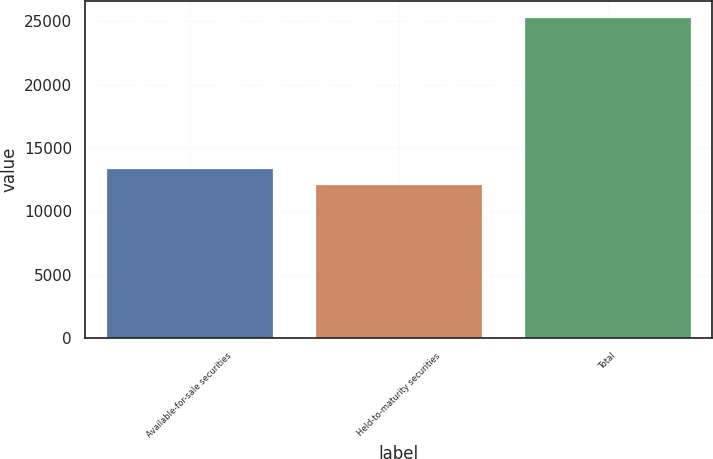Convert chart to OTSL. <chart><loc_0><loc_0><loc_500><loc_500><bar_chart><fcel>Available-for-sale securities<fcel>Held-to-maturity securities<fcel>Total<nl><fcel>13452.7<fcel>12133<fcel>25330<nl></chart> 